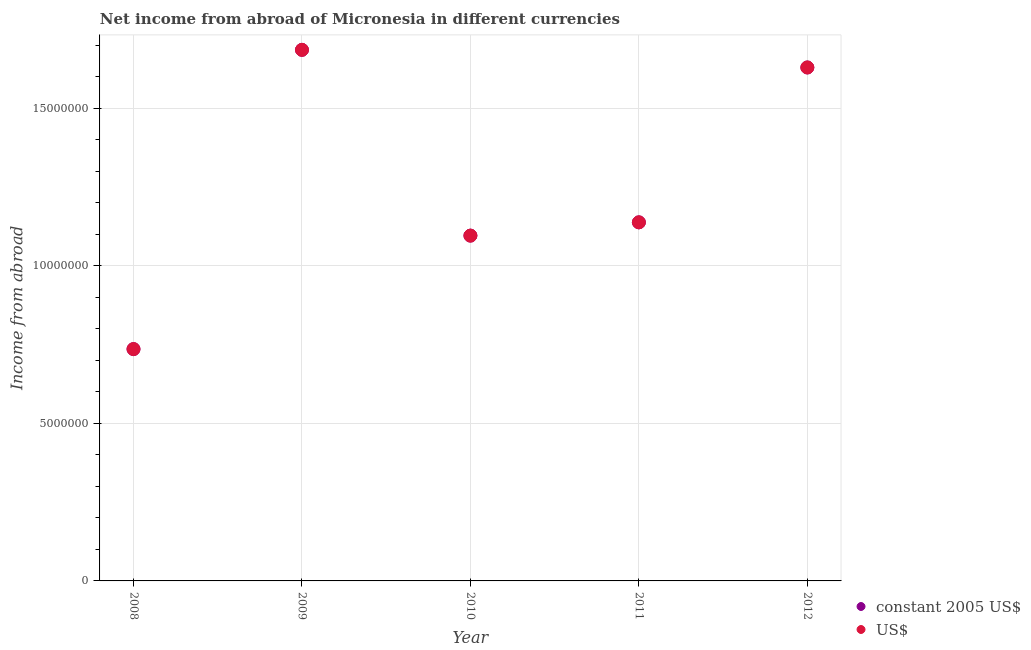What is the income from abroad in constant 2005 us$ in 2010?
Give a very brief answer. 1.10e+07. Across all years, what is the maximum income from abroad in us$?
Give a very brief answer. 1.69e+07. Across all years, what is the minimum income from abroad in constant 2005 us$?
Give a very brief answer. 7.36e+06. What is the total income from abroad in constant 2005 us$ in the graph?
Make the answer very short. 6.29e+07. What is the difference between the income from abroad in constant 2005 us$ in 2008 and that in 2010?
Give a very brief answer. -3.60e+06. What is the difference between the income from abroad in us$ in 2012 and the income from abroad in constant 2005 us$ in 2009?
Your response must be concise. -5.60e+05. What is the average income from abroad in constant 2005 us$ per year?
Keep it short and to the point. 1.26e+07. In the year 2010, what is the difference between the income from abroad in constant 2005 us$ and income from abroad in us$?
Provide a short and direct response. 0. In how many years, is the income from abroad in us$ greater than 15000000 units?
Provide a short and direct response. 2. What is the ratio of the income from abroad in us$ in 2008 to that in 2009?
Provide a succinct answer. 0.44. Is the income from abroad in constant 2005 us$ in 2008 less than that in 2010?
Your answer should be very brief. Yes. What is the difference between the highest and the second highest income from abroad in us$?
Your answer should be compact. 5.60e+05. What is the difference between the highest and the lowest income from abroad in us$?
Provide a short and direct response. 9.50e+06. Is the income from abroad in constant 2005 us$ strictly greater than the income from abroad in us$ over the years?
Offer a very short reply. No. How many years are there in the graph?
Make the answer very short. 5. What is the difference between two consecutive major ticks on the Y-axis?
Provide a short and direct response. 5.00e+06. Does the graph contain any zero values?
Keep it short and to the point. No. Does the graph contain grids?
Keep it short and to the point. Yes. How many legend labels are there?
Offer a very short reply. 2. How are the legend labels stacked?
Provide a short and direct response. Vertical. What is the title of the graph?
Your answer should be very brief. Net income from abroad of Micronesia in different currencies. Does "Excluding technical cooperation" appear as one of the legend labels in the graph?
Provide a short and direct response. No. What is the label or title of the X-axis?
Your answer should be very brief. Year. What is the label or title of the Y-axis?
Offer a very short reply. Income from abroad. What is the Income from abroad of constant 2005 US$ in 2008?
Offer a terse response. 7.36e+06. What is the Income from abroad in US$ in 2008?
Your answer should be compact. 7.36e+06. What is the Income from abroad of constant 2005 US$ in 2009?
Ensure brevity in your answer.  1.69e+07. What is the Income from abroad of US$ in 2009?
Offer a very short reply. 1.69e+07. What is the Income from abroad in constant 2005 US$ in 2010?
Provide a succinct answer. 1.10e+07. What is the Income from abroad in US$ in 2010?
Offer a terse response. 1.10e+07. What is the Income from abroad in constant 2005 US$ in 2011?
Provide a short and direct response. 1.14e+07. What is the Income from abroad in US$ in 2011?
Your answer should be compact. 1.14e+07. What is the Income from abroad in constant 2005 US$ in 2012?
Make the answer very short. 1.63e+07. What is the Income from abroad in US$ in 2012?
Give a very brief answer. 1.63e+07. Across all years, what is the maximum Income from abroad in constant 2005 US$?
Provide a succinct answer. 1.69e+07. Across all years, what is the maximum Income from abroad in US$?
Offer a terse response. 1.69e+07. Across all years, what is the minimum Income from abroad in constant 2005 US$?
Keep it short and to the point. 7.36e+06. Across all years, what is the minimum Income from abroad of US$?
Offer a very short reply. 7.36e+06. What is the total Income from abroad of constant 2005 US$ in the graph?
Your answer should be very brief. 6.29e+07. What is the total Income from abroad of US$ in the graph?
Offer a very short reply. 6.29e+07. What is the difference between the Income from abroad of constant 2005 US$ in 2008 and that in 2009?
Ensure brevity in your answer.  -9.50e+06. What is the difference between the Income from abroad of US$ in 2008 and that in 2009?
Make the answer very short. -9.50e+06. What is the difference between the Income from abroad in constant 2005 US$ in 2008 and that in 2010?
Your answer should be very brief. -3.60e+06. What is the difference between the Income from abroad in US$ in 2008 and that in 2010?
Your answer should be compact. -3.60e+06. What is the difference between the Income from abroad in constant 2005 US$ in 2008 and that in 2011?
Make the answer very short. -4.02e+06. What is the difference between the Income from abroad in US$ in 2008 and that in 2011?
Keep it short and to the point. -4.02e+06. What is the difference between the Income from abroad of constant 2005 US$ in 2008 and that in 2012?
Keep it short and to the point. -8.94e+06. What is the difference between the Income from abroad in US$ in 2008 and that in 2012?
Keep it short and to the point. -8.94e+06. What is the difference between the Income from abroad of constant 2005 US$ in 2009 and that in 2010?
Offer a terse response. 5.90e+06. What is the difference between the Income from abroad of US$ in 2009 and that in 2010?
Make the answer very short. 5.90e+06. What is the difference between the Income from abroad of constant 2005 US$ in 2009 and that in 2011?
Keep it short and to the point. 5.48e+06. What is the difference between the Income from abroad of US$ in 2009 and that in 2011?
Your answer should be very brief. 5.48e+06. What is the difference between the Income from abroad in constant 2005 US$ in 2009 and that in 2012?
Give a very brief answer. 5.60e+05. What is the difference between the Income from abroad in US$ in 2009 and that in 2012?
Provide a short and direct response. 5.60e+05. What is the difference between the Income from abroad of constant 2005 US$ in 2010 and that in 2011?
Give a very brief answer. -4.22e+05. What is the difference between the Income from abroad in US$ in 2010 and that in 2011?
Make the answer very short. -4.22e+05. What is the difference between the Income from abroad in constant 2005 US$ in 2010 and that in 2012?
Offer a very short reply. -5.34e+06. What is the difference between the Income from abroad of US$ in 2010 and that in 2012?
Your answer should be compact. -5.34e+06. What is the difference between the Income from abroad in constant 2005 US$ in 2011 and that in 2012?
Your response must be concise. -4.92e+06. What is the difference between the Income from abroad of US$ in 2011 and that in 2012?
Keep it short and to the point. -4.92e+06. What is the difference between the Income from abroad of constant 2005 US$ in 2008 and the Income from abroad of US$ in 2009?
Offer a terse response. -9.50e+06. What is the difference between the Income from abroad of constant 2005 US$ in 2008 and the Income from abroad of US$ in 2010?
Offer a very short reply. -3.60e+06. What is the difference between the Income from abroad of constant 2005 US$ in 2008 and the Income from abroad of US$ in 2011?
Make the answer very short. -4.02e+06. What is the difference between the Income from abroad of constant 2005 US$ in 2008 and the Income from abroad of US$ in 2012?
Give a very brief answer. -8.94e+06. What is the difference between the Income from abroad in constant 2005 US$ in 2009 and the Income from abroad in US$ in 2010?
Make the answer very short. 5.90e+06. What is the difference between the Income from abroad in constant 2005 US$ in 2009 and the Income from abroad in US$ in 2011?
Your answer should be compact. 5.48e+06. What is the difference between the Income from abroad of constant 2005 US$ in 2009 and the Income from abroad of US$ in 2012?
Make the answer very short. 5.60e+05. What is the difference between the Income from abroad of constant 2005 US$ in 2010 and the Income from abroad of US$ in 2011?
Offer a terse response. -4.22e+05. What is the difference between the Income from abroad of constant 2005 US$ in 2010 and the Income from abroad of US$ in 2012?
Offer a very short reply. -5.34e+06. What is the difference between the Income from abroad of constant 2005 US$ in 2011 and the Income from abroad of US$ in 2012?
Offer a very short reply. -4.92e+06. What is the average Income from abroad of constant 2005 US$ per year?
Your answer should be compact. 1.26e+07. What is the average Income from abroad of US$ per year?
Your answer should be very brief. 1.26e+07. In the year 2008, what is the difference between the Income from abroad of constant 2005 US$ and Income from abroad of US$?
Provide a short and direct response. 0. In the year 2009, what is the difference between the Income from abroad in constant 2005 US$ and Income from abroad in US$?
Your response must be concise. 0. What is the ratio of the Income from abroad in constant 2005 US$ in 2008 to that in 2009?
Give a very brief answer. 0.44. What is the ratio of the Income from abroad of US$ in 2008 to that in 2009?
Provide a short and direct response. 0.44. What is the ratio of the Income from abroad in constant 2005 US$ in 2008 to that in 2010?
Provide a succinct answer. 0.67. What is the ratio of the Income from abroad of US$ in 2008 to that in 2010?
Keep it short and to the point. 0.67. What is the ratio of the Income from abroad in constant 2005 US$ in 2008 to that in 2011?
Provide a succinct answer. 0.65. What is the ratio of the Income from abroad in US$ in 2008 to that in 2011?
Give a very brief answer. 0.65. What is the ratio of the Income from abroad in constant 2005 US$ in 2008 to that in 2012?
Offer a terse response. 0.45. What is the ratio of the Income from abroad of US$ in 2008 to that in 2012?
Keep it short and to the point. 0.45. What is the ratio of the Income from abroad in constant 2005 US$ in 2009 to that in 2010?
Keep it short and to the point. 1.54. What is the ratio of the Income from abroad of US$ in 2009 to that in 2010?
Make the answer very short. 1.54. What is the ratio of the Income from abroad of constant 2005 US$ in 2009 to that in 2011?
Provide a succinct answer. 1.48. What is the ratio of the Income from abroad in US$ in 2009 to that in 2011?
Offer a very short reply. 1.48. What is the ratio of the Income from abroad of constant 2005 US$ in 2009 to that in 2012?
Ensure brevity in your answer.  1.03. What is the ratio of the Income from abroad in US$ in 2009 to that in 2012?
Keep it short and to the point. 1.03. What is the ratio of the Income from abroad of constant 2005 US$ in 2010 to that in 2011?
Your response must be concise. 0.96. What is the ratio of the Income from abroad of US$ in 2010 to that in 2011?
Offer a very short reply. 0.96. What is the ratio of the Income from abroad in constant 2005 US$ in 2010 to that in 2012?
Provide a short and direct response. 0.67. What is the ratio of the Income from abroad of US$ in 2010 to that in 2012?
Ensure brevity in your answer.  0.67. What is the ratio of the Income from abroad of constant 2005 US$ in 2011 to that in 2012?
Your answer should be very brief. 0.7. What is the ratio of the Income from abroad in US$ in 2011 to that in 2012?
Offer a very short reply. 0.7. What is the difference between the highest and the second highest Income from abroad in constant 2005 US$?
Provide a short and direct response. 5.60e+05. What is the difference between the highest and the second highest Income from abroad of US$?
Provide a short and direct response. 5.60e+05. What is the difference between the highest and the lowest Income from abroad of constant 2005 US$?
Offer a very short reply. 9.50e+06. What is the difference between the highest and the lowest Income from abroad of US$?
Your answer should be compact. 9.50e+06. 